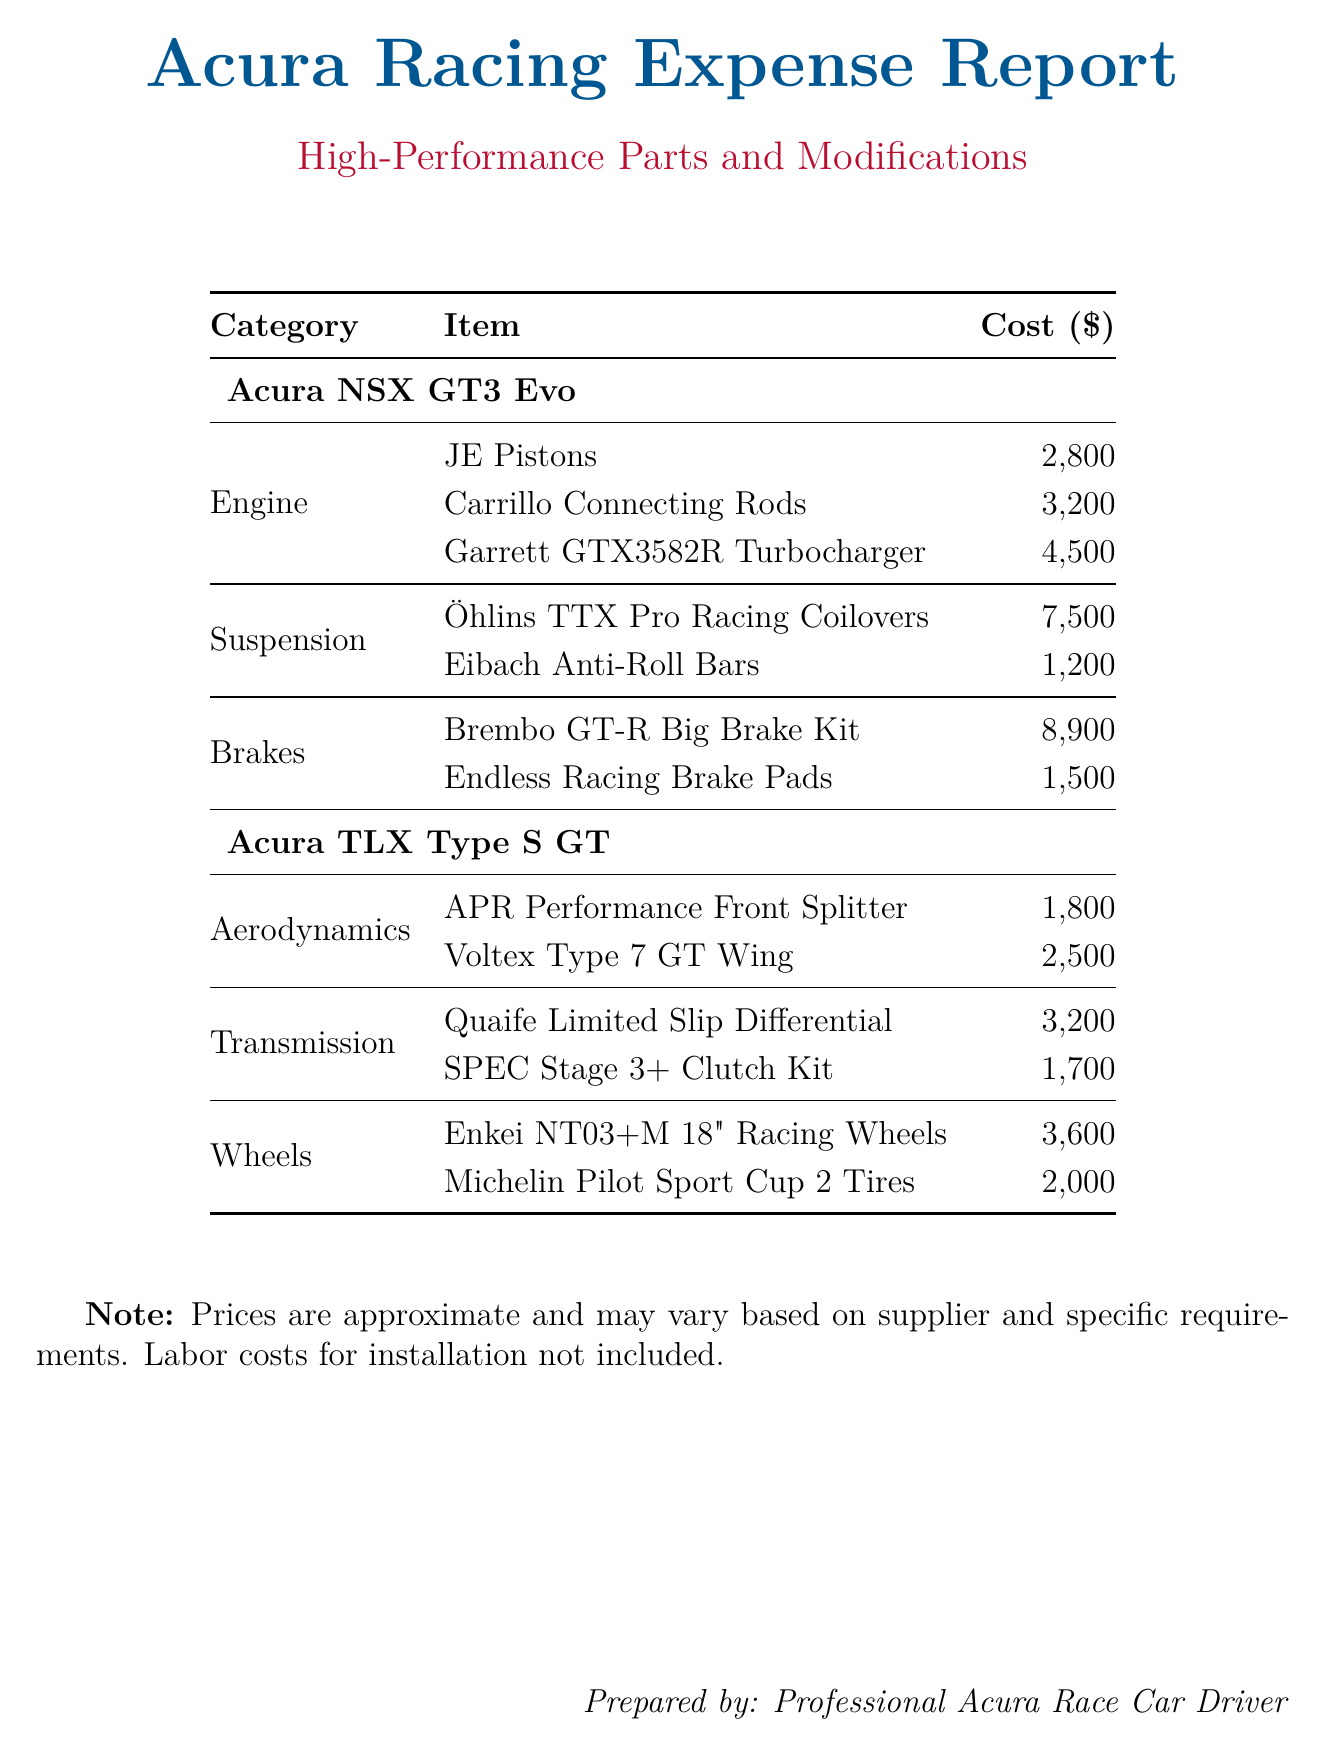What is the total expense for the Acura NSX GT3 Evo? The total expense for the Acura NSX GT3 Evo can be calculated by summing the individual expenses listed in the document, which amounts to $2800 + $3200 + $4500 + $7500 + $1200 + $8900 + $1500 = $25,100.
Answer: $25,100 Which item costs the most in the suspension category for the Acura NSX GT3 Evo? The most expensive item in the suspension category for the Acura NSX GT3 Evo is Öhlins TTX Pro Racing Coilovers, which costs $7500.
Answer: Öhlins TTX Pro Racing Coilovers What category does the Garrett GTX3582R Turbocharger fall under? The Garrett GTX3582R Turbocharger is categorized under Engine in the Acura NSX GT3 Evo section.
Answer: Engine What is the total expense for the Acura TLX Type S GT wheels category? The total expense for the wheels category in the Acura TLX Type S GT is calculated by adding the costs for the items Enkei NT03+M 18" Racing Wheels ($3600) and Michelin Pilot Sport Cup 2 Tires ($2000), totaling $5600.
Answer: $5600 How many items are listed in the brakes category for the Acura NSX GT3 Evo? There are two items listed in the brakes category for the Acura NSX GT3 Evo, which are the Brembo GT-R Big Brake Kit and Endless Racing Brake Pads.
Answer: 2 